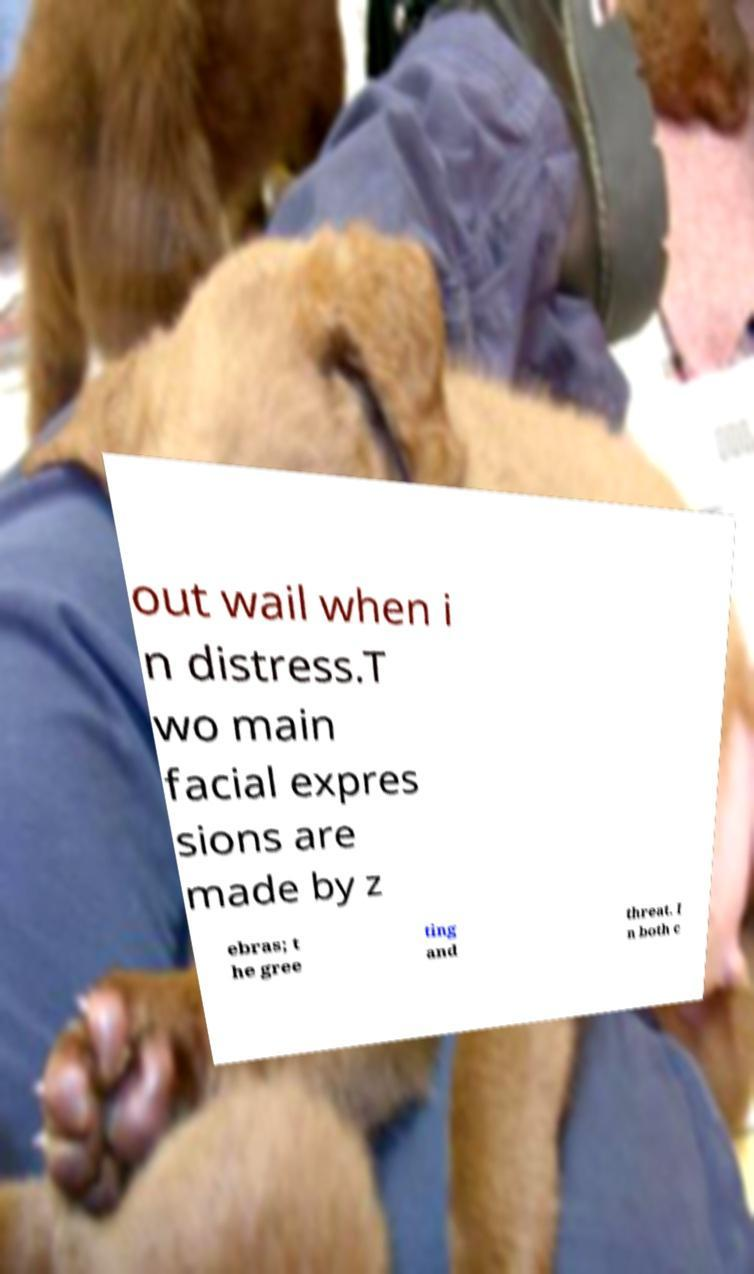I need the written content from this picture converted into text. Can you do that? out wail when i n distress.T wo main facial expres sions are made by z ebras; t he gree ting and threat. I n both c 